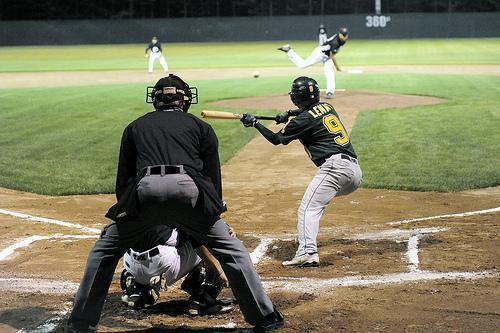How many people are shown in this photo?
Give a very brief answer. 6. 